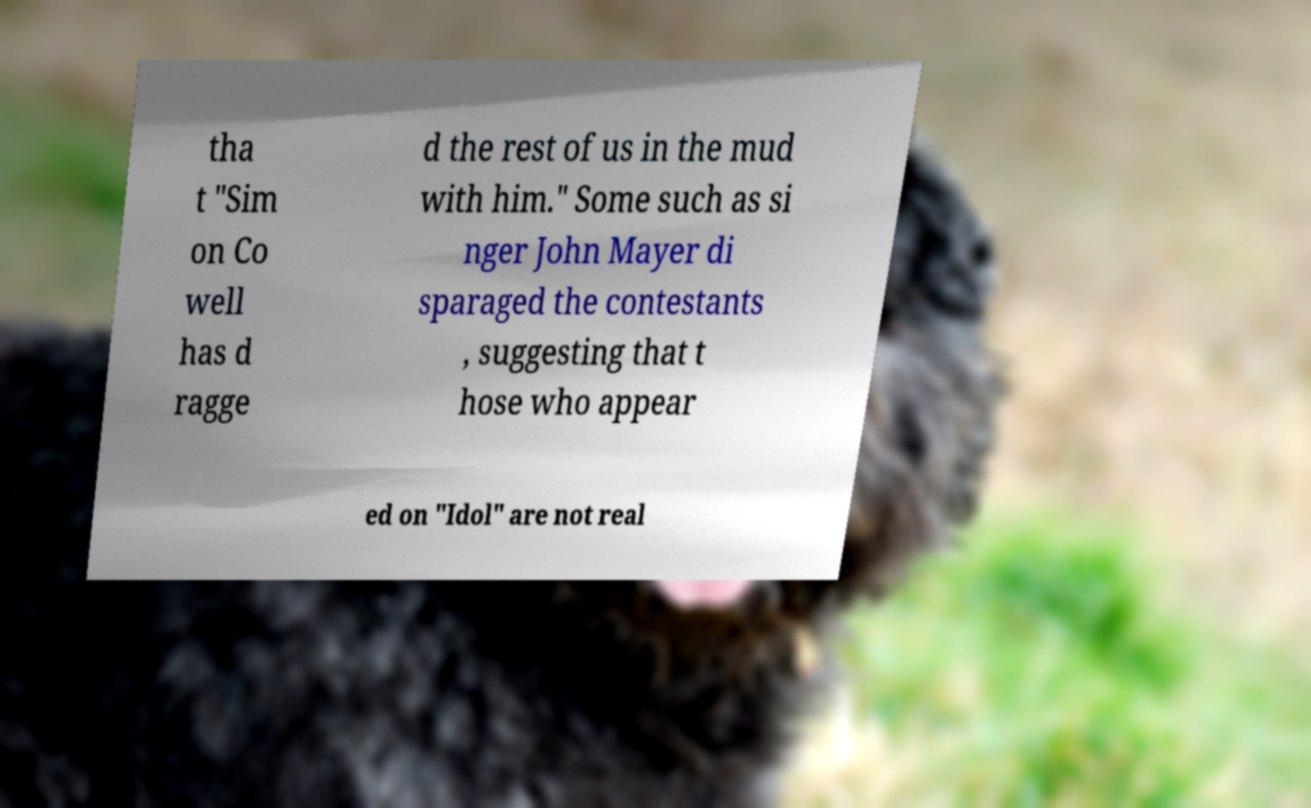Can you read and provide the text displayed in the image?This photo seems to have some interesting text. Can you extract and type it out for me? tha t "Sim on Co well has d ragge d the rest of us in the mud with him." Some such as si nger John Mayer di sparaged the contestants , suggesting that t hose who appear ed on "Idol" are not real 